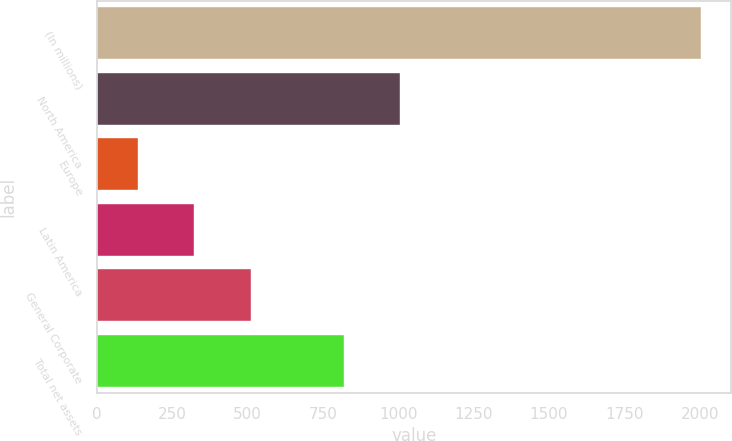<chart> <loc_0><loc_0><loc_500><loc_500><bar_chart><fcel>(In millions)<fcel>North America<fcel>Europe<fcel>Latin America<fcel>General Corporate<fcel>Total net assets<nl><fcel>2005<fcel>1007.09<fcel>137.1<fcel>323.89<fcel>510.68<fcel>820.3<nl></chart> 